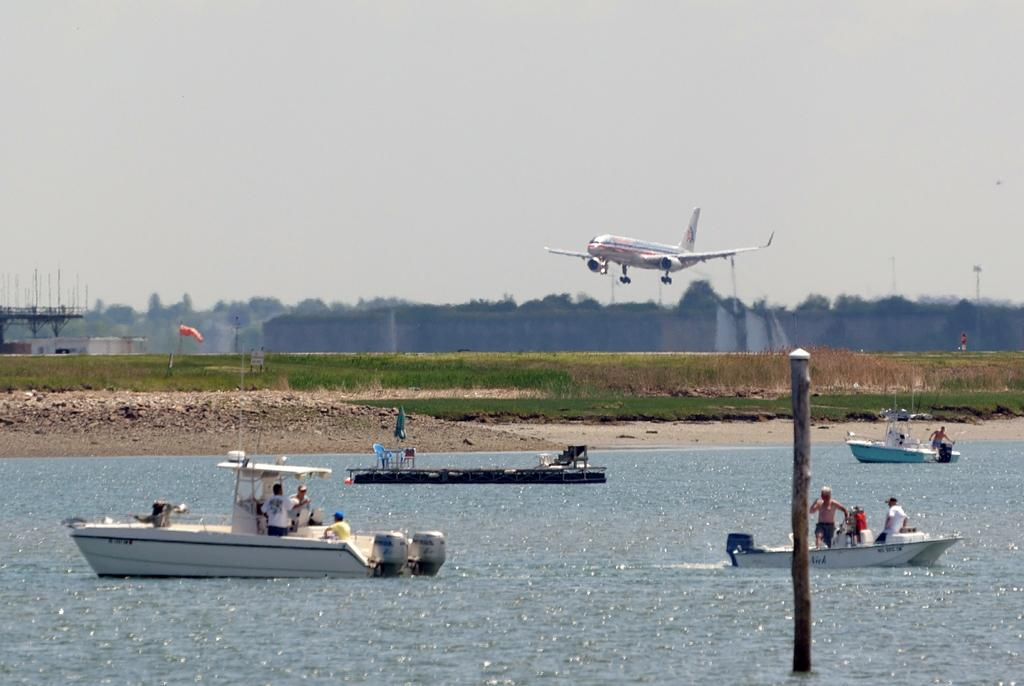What is happening at the bottom of the image? There are persons in a boat at the bottom of the image. What is the boat doing in the image? The boat is sailing on the water. Can you describe any objects visible in the image? There is a pole visible in the image. What can be seen in the background of the image? There is grass, an airplane, trees, and the sky visible in the background of the image. What note is being played by the persons in the boat? There is no indication in the image that the persons in the boat are playing a musical instrument or note. How are the trees blowing in the background of the image? The image is a still representation, so the trees are not actually blowing; they are stationary. 